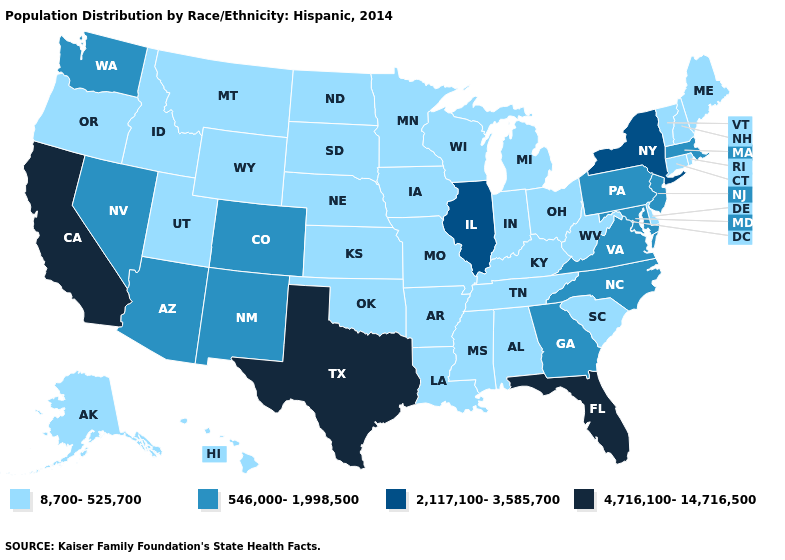How many symbols are there in the legend?
Concise answer only. 4. Does Oklahoma have the lowest value in the South?
Write a very short answer. Yes. Does North Carolina have the same value as Alabama?
Concise answer only. No. Which states hav the highest value in the MidWest?
Concise answer only. Illinois. Name the states that have a value in the range 2,117,100-3,585,700?
Give a very brief answer. Illinois, New York. Among the states that border Montana , which have the lowest value?
Give a very brief answer. Idaho, North Dakota, South Dakota, Wyoming. What is the value of Tennessee?
Be succinct. 8,700-525,700. Does Nevada have a higher value than Virginia?
Give a very brief answer. No. Which states hav the highest value in the Northeast?
Short answer required. New York. Which states have the highest value in the USA?
Keep it brief. California, Florida, Texas. Name the states that have a value in the range 4,716,100-14,716,500?
Short answer required. California, Florida, Texas. Name the states that have a value in the range 2,117,100-3,585,700?
Write a very short answer. Illinois, New York. Does the map have missing data?
Quick response, please. No. What is the lowest value in the West?
Answer briefly. 8,700-525,700. Which states have the lowest value in the MidWest?
Concise answer only. Indiana, Iowa, Kansas, Michigan, Minnesota, Missouri, Nebraska, North Dakota, Ohio, South Dakota, Wisconsin. 